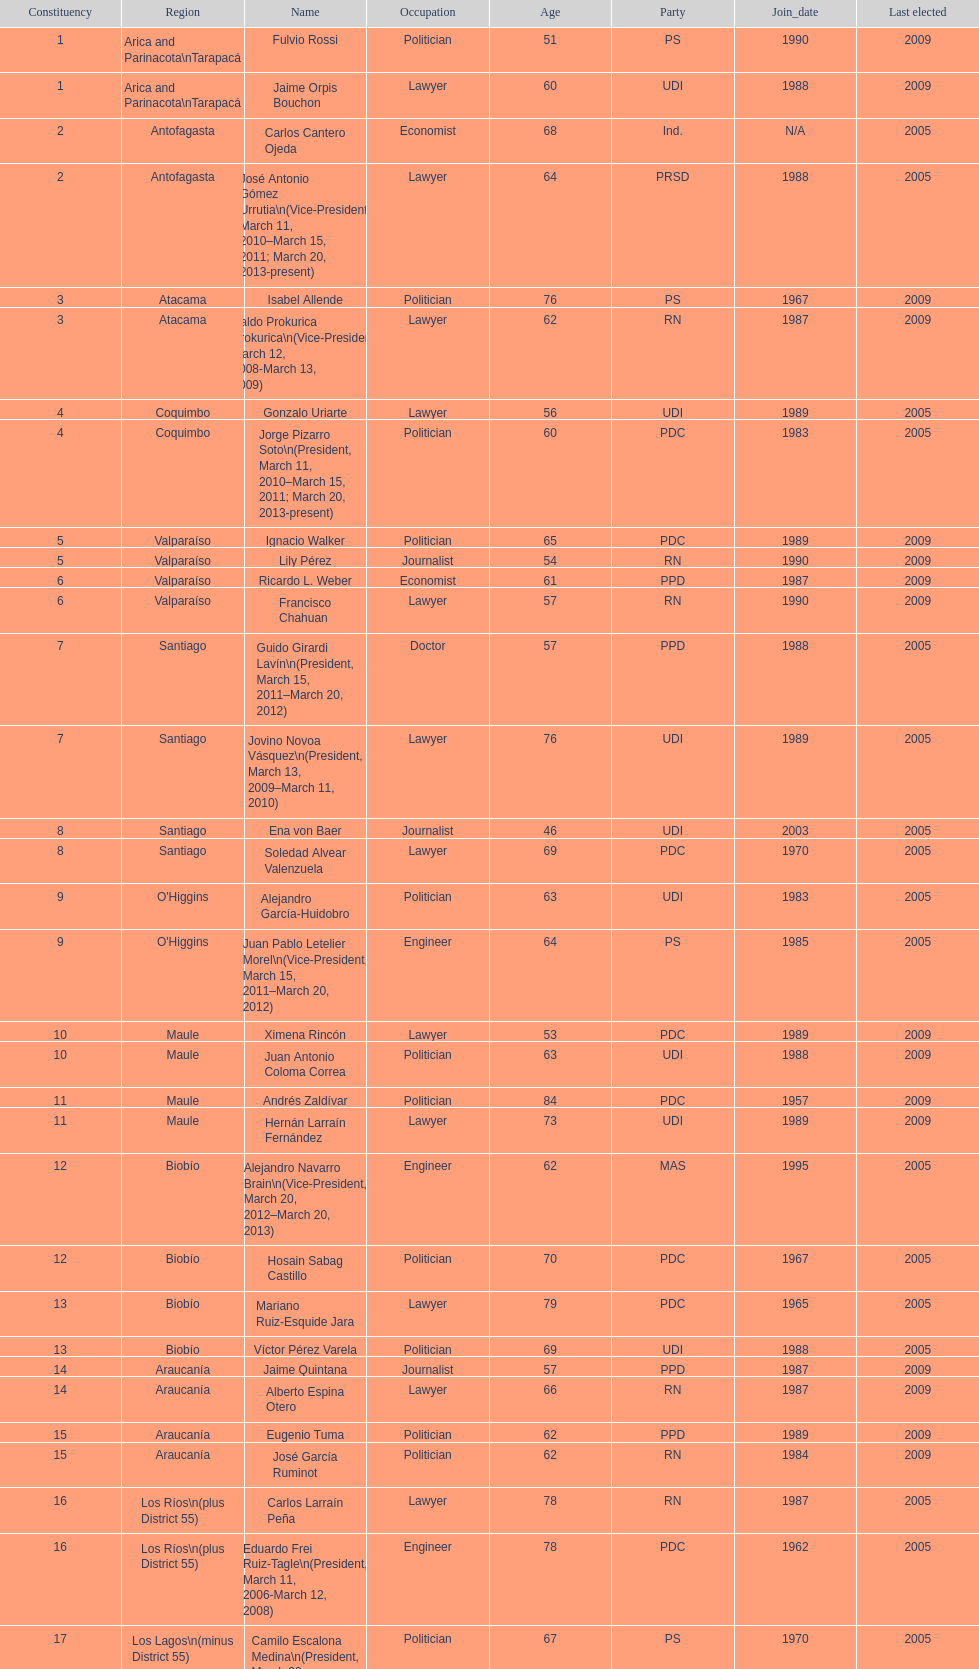Which region is listed below atacama? Coquimbo. 